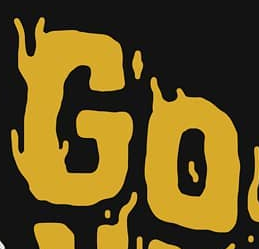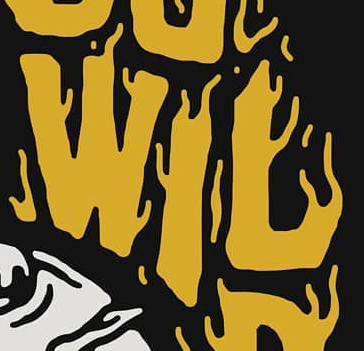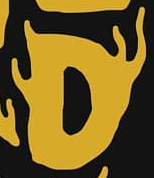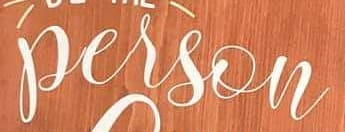Read the text content from these images in order, separated by a semicolon. GO; WIL; D; person 